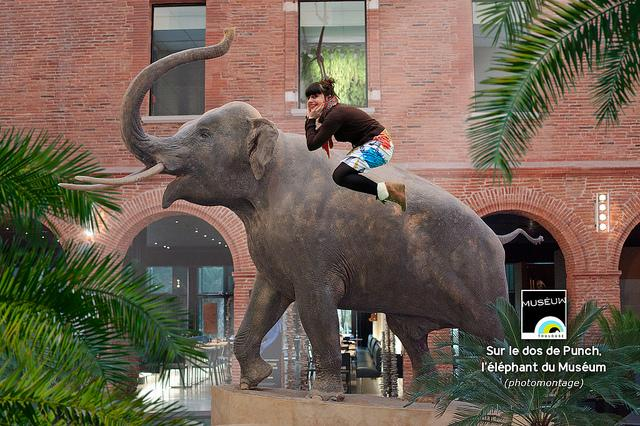What happened to this image?

Choices:
A) blurred
B) photoshopped
C) too dark
D) too bright photoshopped 